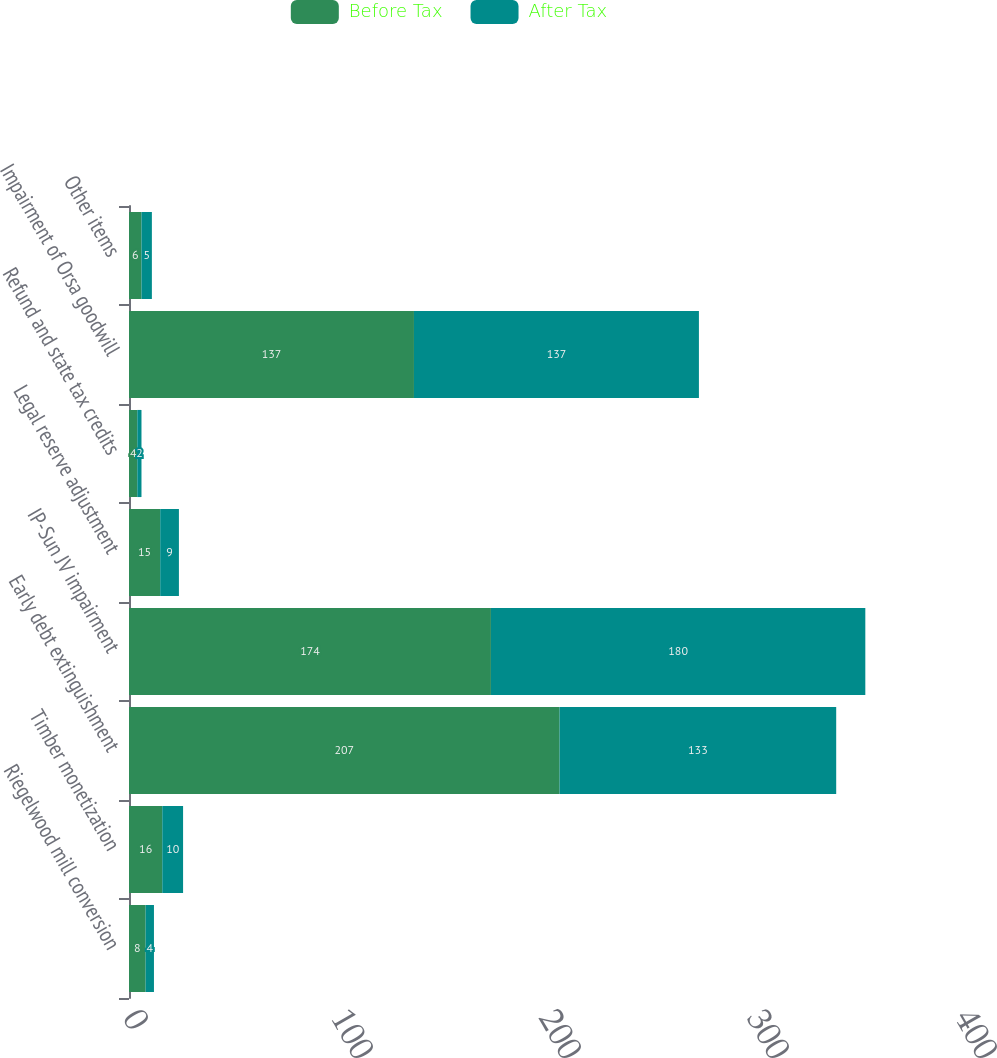Convert chart. <chart><loc_0><loc_0><loc_500><loc_500><stacked_bar_chart><ecel><fcel>Riegelwood mill conversion<fcel>Timber monetization<fcel>Early debt extinguishment<fcel>IP-Sun JV impairment<fcel>Legal reserve adjustment<fcel>Refund and state tax credits<fcel>Impairment of Orsa goodwill<fcel>Other items<nl><fcel>Before Tax<fcel>8<fcel>16<fcel>207<fcel>174<fcel>15<fcel>4<fcel>137<fcel>6<nl><fcel>After Tax<fcel>4<fcel>10<fcel>133<fcel>180<fcel>9<fcel>2<fcel>137<fcel>5<nl></chart> 